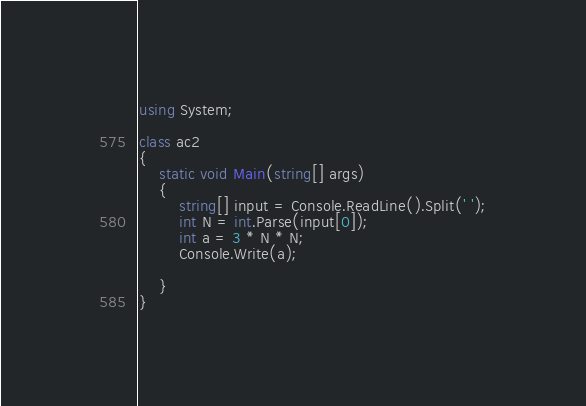Convert code to text. <code><loc_0><loc_0><loc_500><loc_500><_C#_>using System;

class ac2
{
    static void Main(string[] args)
    {
        string[] input = Console.ReadLine().Split(' ');
        int N = int.Parse(input[0]);
        int a = 3 * N * N;
        Console.Write(a);
        
    }
}
</code> 